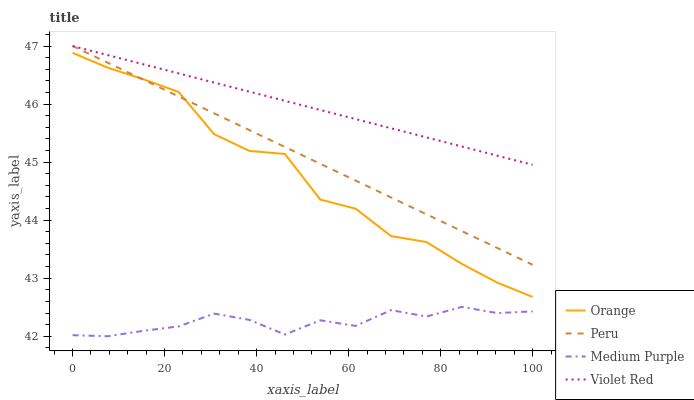Does Medium Purple have the minimum area under the curve?
Answer yes or no. Yes. Does Violet Red have the maximum area under the curve?
Answer yes or no. Yes. Does Violet Red have the minimum area under the curve?
Answer yes or no. No. Does Medium Purple have the maximum area under the curve?
Answer yes or no. No. Is Violet Red the smoothest?
Answer yes or no. Yes. Is Orange the roughest?
Answer yes or no. Yes. Is Medium Purple the smoothest?
Answer yes or no. No. Is Medium Purple the roughest?
Answer yes or no. No. Does Violet Red have the lowest value?
Answer yes or no. No. Does Peru have the highest value?
Answer yes or no. Yes. Does Medium Purple have the highest value?
Answer yes or no. No. Is Orange less than Violet Red?
Answer yes or no. Yes. Is Violet Red greater than Orange?
Answer yes or no. Yes. Does Peru intersect Violet Red?
Answer yes or no. Yes. Is Peru less than Violet Red?
Answer yes or no. No. Is Peru greater than Violet Red?
Answer yes or no. No. Does Orange intersect Violet Red?
Answer yes or no. No. 